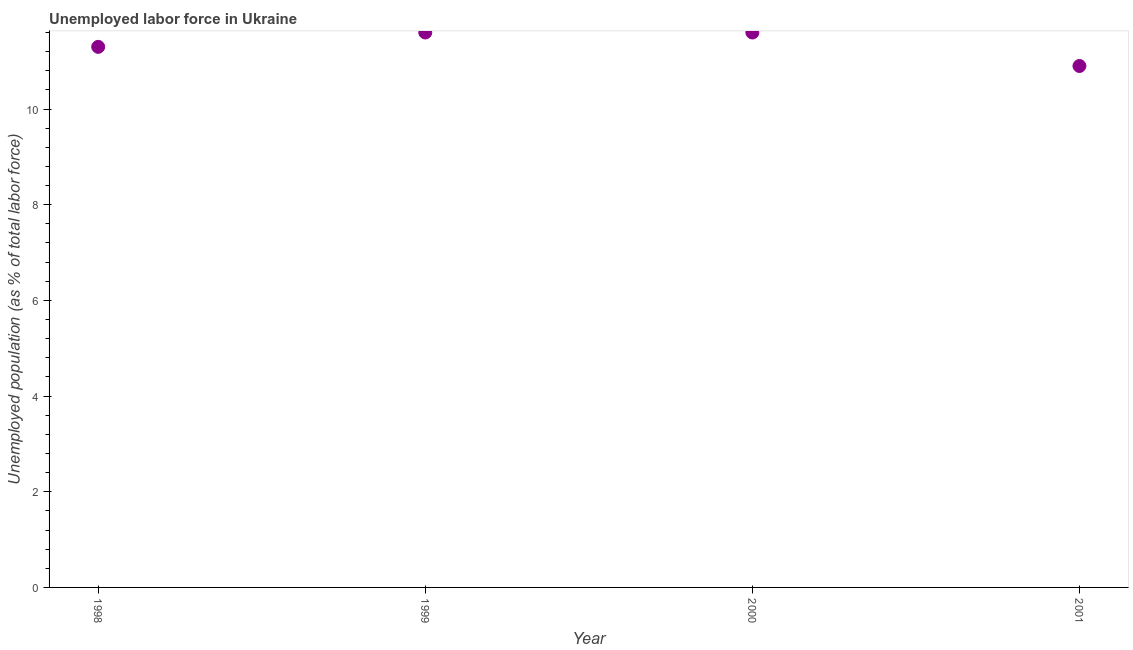What is the total unemployed population in 2000?
Offer a terse response. 11.6. Across all years, what is the maximum total unemployed population?
Your answer should be compact. 11.6. Across all years, what is the minimum total unemployed population?
Provide a short and direct response. 10.9. What is the sum of the total unemployed population?
Your answer should be very brief. 45.4. What is the difference between the total unemployed population in 1998 and 1999?
Ensure brevity in your answer.  -0.3. What is the average total unemployed population per year?
Provide a short and direct response. 11.35. What is the median total unemployed population?
Give a very brief answer. 11.45. Do a majority of the years between 2001 and 1998 (inclusive) have total unemployed population greater than 9.6 %?
Offer a very short reply. Yes. What is the ratio of the total unemployed population in 1999 to that in 2000?
Provide a succinct answer. 1. Is the difference between the total unemployed population in 1998 and 1999 greater than the difference between any two years?
Provide a succinct answer. No. What is the difference between the highest and the second highest total unemployed population?
Your answer should be compact. 0. Is the sum of the total unemployed population in 2000 and 2001 greater than the maximum total unemployed population across all years?
Your answer should be compact. Yes. What is the difference between the highest and the lowest total unemployed population?
Offer a terse response. 0.7. How many dotlines are there?
Provide a succinct answer. 1. What is the difference between two consecutive major ticks on the Y-axis?
Offer a very short reply. 2. Does the graph contain any zero values?
Keep it short and to the point. No. Does the graph contain grids?
Your answer should be compact. No. What is the title of the graph?
Your answer should be very brief. Unemployed labor force in Ukraine. What is the label or title of the X-axis?
Your response must be concise. Year. What is the label or title of the Y-axis?
Offer a very short reply. Unemployed population (as % of total labor force). What is the Unemployed population (as % of total labor force) in 1998?
Ensure brevity in your answer.  11.3. What is the Unemployed population (as % of total labor force) in 1999?
Your answer should be very brief. 11.6. What is the Unemployed population (as % of total labor force) in 2000?
Offer a terse response. 11.6. What is the Unemployed population (as % of total labor force) in 2001?
Keep it short and to the point. 10.9. What is the difference between the Unemployed population (as % of total labor force) in 1999 and 2000?
Keep it short and to the point. 0. What is the difference between the Unemployed population (as % of total labor force) in 2000 and 2001?
Ensure brevity in your answer.  0.7. What is the ratio of the Unemployed population (as % of total labor force) in 1998 to that in 1999?
Offer a terse response. 0.97. What is the ratio of the Unemployed population (as % of total labor force) in 1999 to that in 2000?
Ensure brevity in your answer.  1. What is the ratio of the Unemployed population (as % of total labor force) in 1999 to that in 2001?
Your answer should be compact. 1.06. What is the ratio of the Unemployed population (as % of total labor force) in 2000 to that in 2001?
Ensure brevity in your answer.  1.06. 